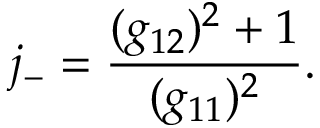<formula> <loc_0><loc_0><loc_500><loc_500>j _ { - } = \frac { ( g _ { 1 2 } ) ^ { 2 } + 1 } { ( g _ { 1 1 } ) ^ { 2 } } .</formula> 